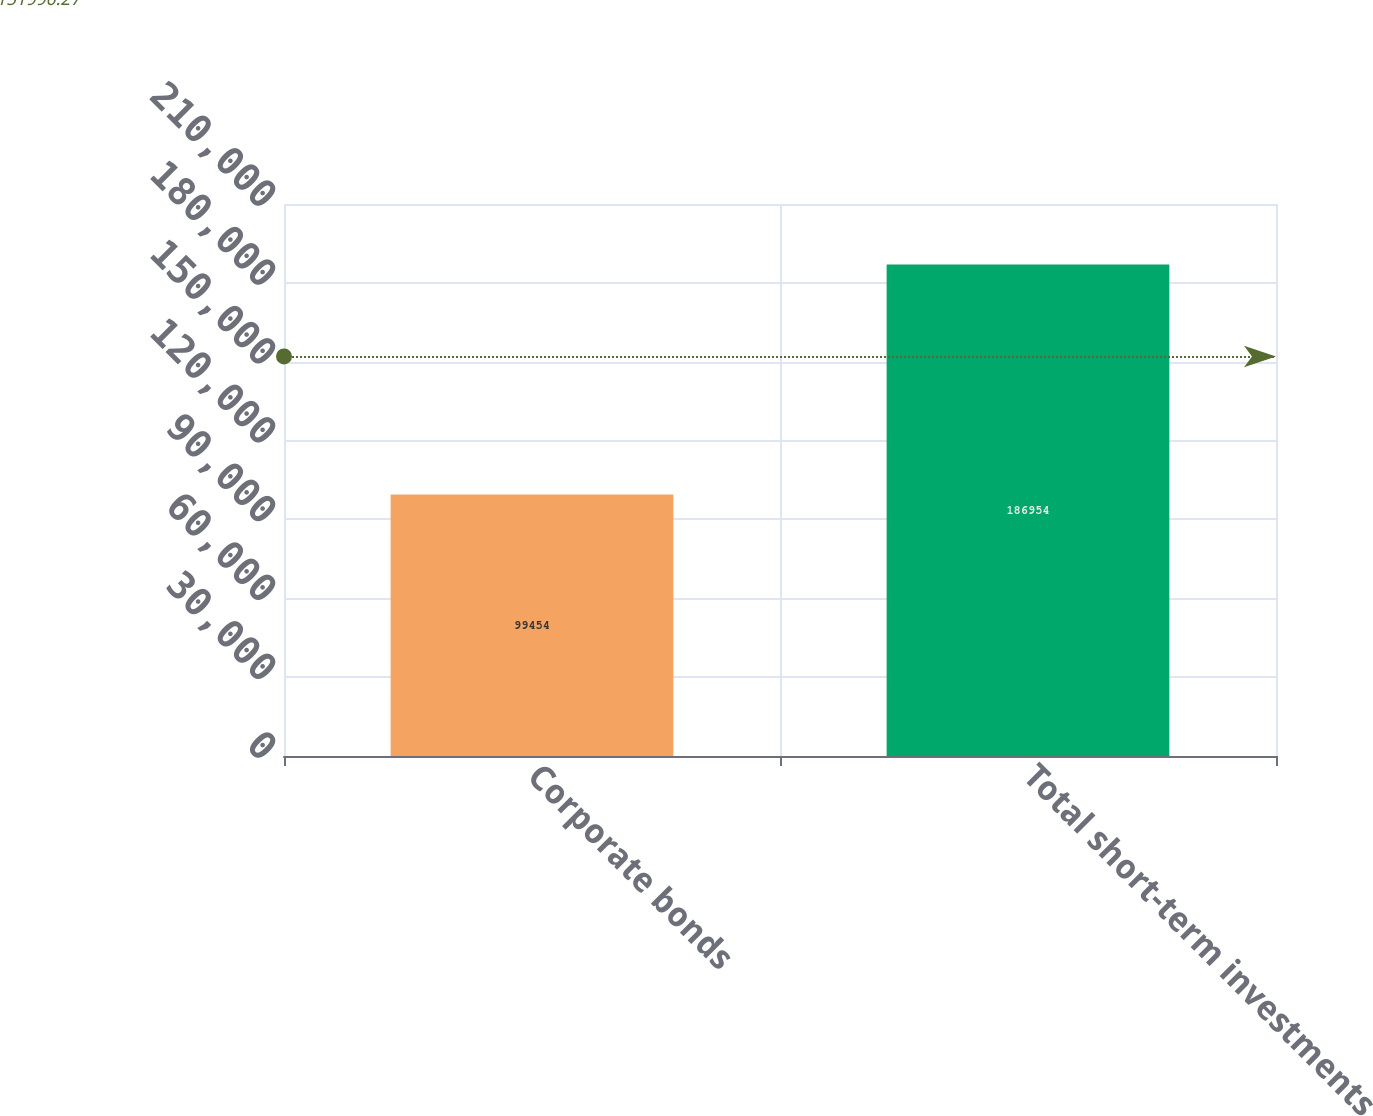<chart> <loc_0><loc_0><loc_500><loc_500><bar_chart><fcel>Corporate bonds<fcel>Total short-term investments<nl><fcel>99454<fcel>186954<nl></chart> 